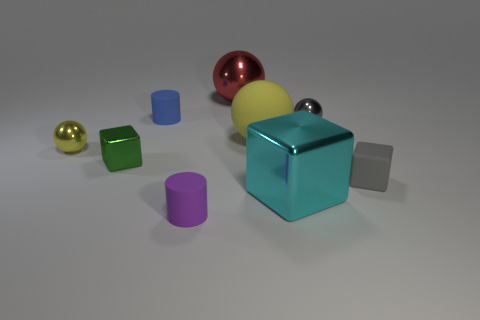Subtract all green cubes. How many cubes are left? 2 Subtract all purple cylinders. How many cylinders are left? 1 Add 1 small gray cubes. How many objects exist? 10 Subtract all cylinders. How many objects are left? 7 Subtract 0 green spheres. How many objects are left? 9 Subtract 4 spheres. How many spheres are left? 0 Subtract all red cylinders. Subtract all blue cubes. How many cylinders are left? 2 Subtract all yellow blocks. How many yellow spheres are left? 2 Subtract all big yellow rubber things. Subtract all gray things. How many objects are left? 6 Add 3 red shiny spheres. How many red shiny spheres are left? 4 